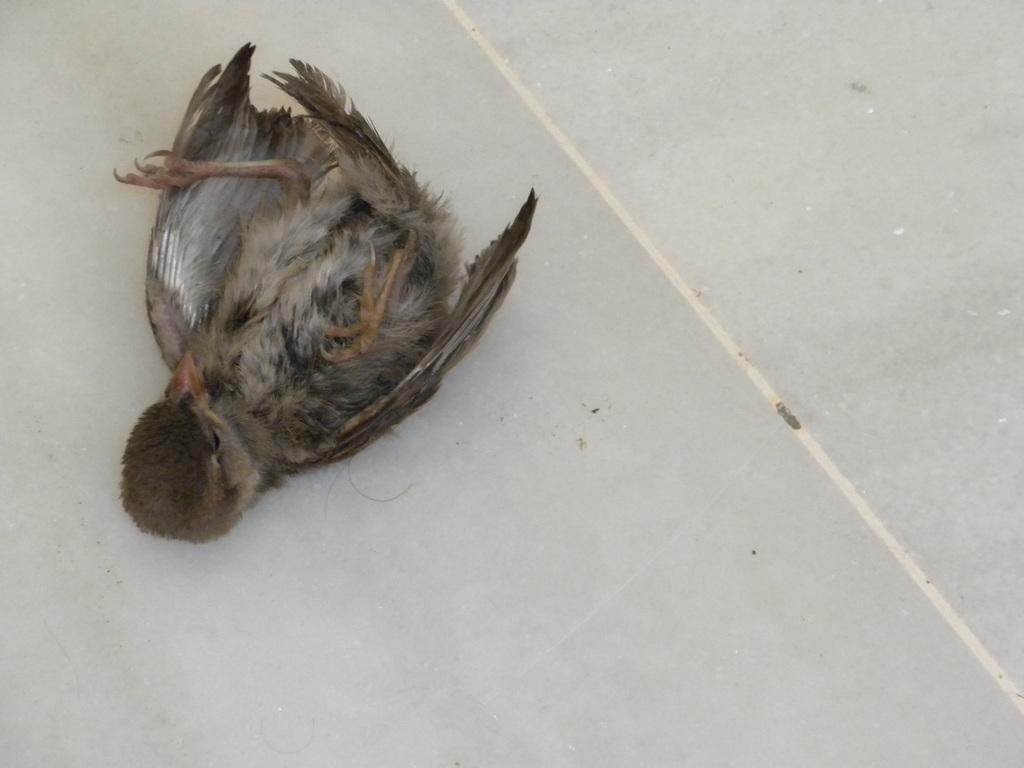Please provide a concise description of this image. At the bottom of the image there is a floor. The floor is white in color. In the middle of the image there is a bird on the floor. 